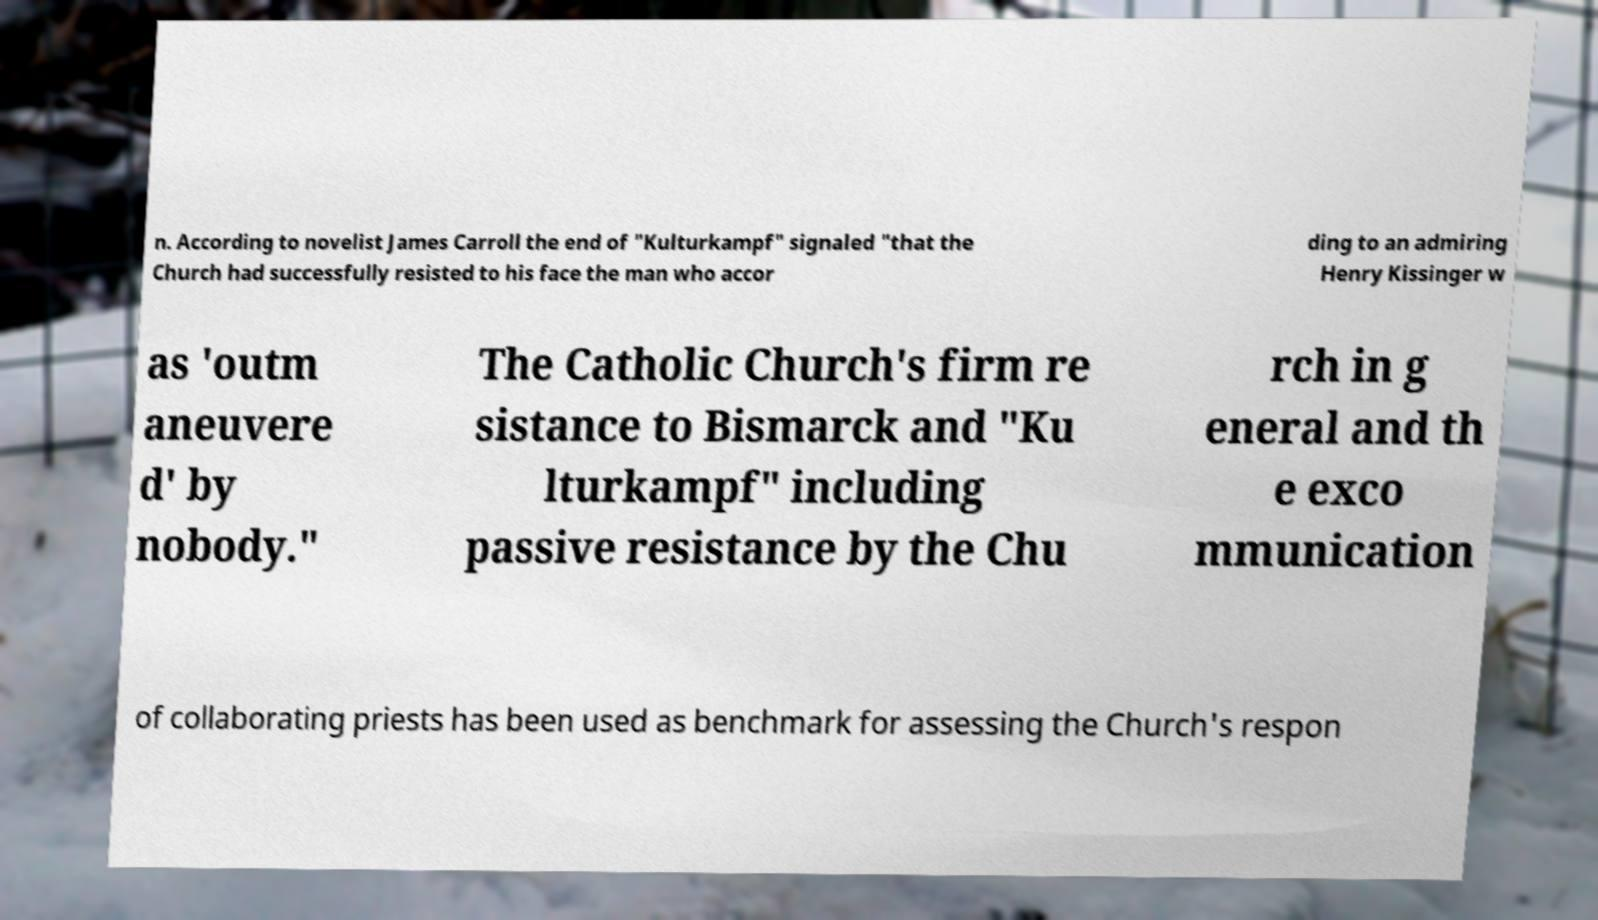Please identify and transcribe the text found in this image. n. According to novelist James Carroll the end of "Kulturkampf" signaled "that the Church had successfully resisted to his face the man who accor ding to an admiring Henry Kissinger w as 'outm aneuvere d' by nobody." The Catholic Church's firm re sistance to Bismarck and "Ku lturkampf" including passive resistance by the Chu rch in g eneral and th e exco mmunication of collaborating priests has been used as benchmark for assessing the Church's respon 